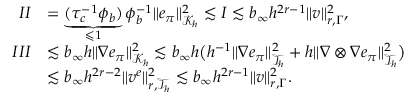Convert formula to latex. <formula><loc_0><loc_0><loc_500><loc_500>\begin{array} { r l } { I I } & { = \underbrace { ( \tau _ { c } ^ { - 1 } \phi _ { b } ) } _ { \leqslant 1 } \phi _ { b } ^ { - 1 } \| e _ { \pi } \| _ { \mathcal { K } _ { h } } ^ { 2 } \lesssim I \lesssim b _ { \infty } h ^ { 2 r - 1 } \| v \| _ { r , \Gamma } ^ { 2 } , } \\ { I I I } & { \lesssim b _ { \infty } h \| \nabla e _ { \pi } \| _ { \mathcal { K } _ { h } } ^ { 2 } \lesssim b _ { \infty } h \left ( h ^ { - 1 } \| \nabla e _ { \pi } \| _ { \mathcal { T } _ { h } } ^ { 2 } + h \| \nabla \otimes \nabla e _ { \pi } \| _ { \mathcal { T } _ { h } } ^ { 2 } \right ) } \\ & { \lesssim b _ { \infty } h ^ { 2 r - 2 } \| v ^ { e } \| _ { r , \mathcal { T } _ { h } } ^ { 2 } \lesssim b _ { \infty } h ^ { 2 r - 1 } \| v \| _ { r , \Gamma } ^ { 2 } . } \end{array}</formula> 